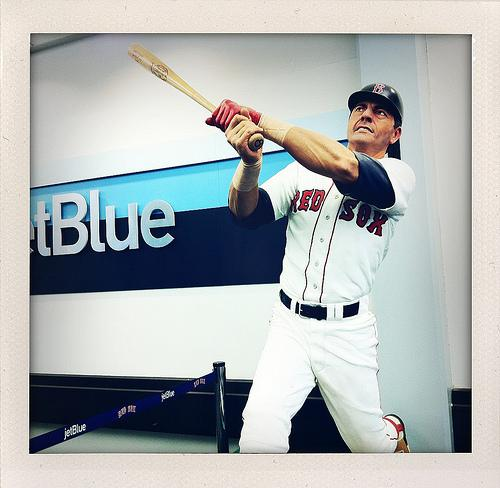Question: who is holding a bat?
Choices:
A. The baseball player.
B. The boy.
C. The girl.
D. The coach.
Answer with the letter. Answer: A Question: how many dogs are there?
Choices:
A. One.
B. Three.
C. Zero.
D. Two.
Answer with the letter. Answer: C Question: what color is the man's belt?
Choices:
A. Brown.
B. Tan.
C. Red.
D. Black.
Answer with the letter. Answer: D Question: what baseball team is represented?
Choices:
A. Red Sox.
B. White Sox.
C. Blue Sox.
D. Black Sox.
Answer with the letter. Answer: A Question: what airline's logo is on the wall?
Choices:
A. JetBlue.
B. Swiss Air.
C. Air France.
D. British Airways.
Answer with the letter. Answer: A 